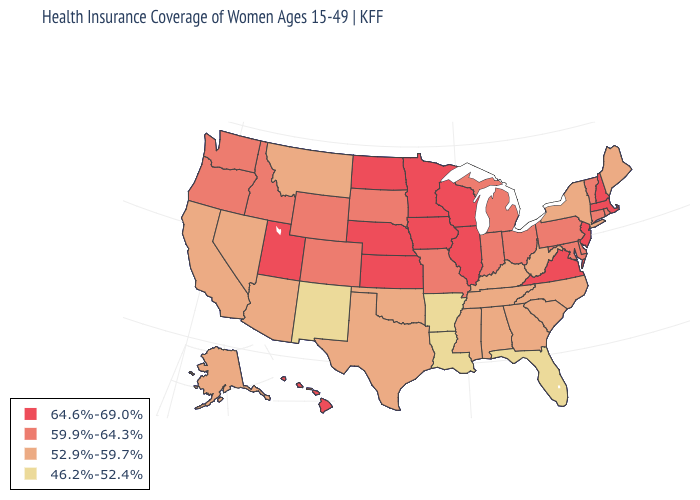Which states hav the highest value in the West?
Keep it brief. Hawaii, Utah. What is the value of Indiana?
Short answer required. 59.9%-64.3%. Name the states that have a value in the range 46.2%-52.4%?
Give a very brief answer. Arkansas, Florida, Louisiana, New Mexico. Does New Jersey have the highest value in the USA?
Keep it brief. Yes. What is the value of Iowa?
Short answer required. 64.6%-69.0%. What is the value of Minnesota?
Quick response, please. 64.6%-69.0%. What is the value of South Carolina?
Give a very brief answer. 52.9%-59.7%. What is the value of Texas?
Concise answer only. 52.9%-59.7%. What is the value of Delaware?
Keep it brief. 59.9%-64.3%. Name the states that have a value in the range 59.9%-64.3%?
Quick response, please. Colorado, Connecticut, Delaware, Idaho, Indiana, Maryland, Michigan, Missouri, Ohio, Oregon, Pennsylvania, Rhode Island, South Dakota, Vermont, Washington, Wyoming. Does Alaska have the same value as Minnesota?
Keep it brief. No. What is the highest value in the USA?
Be succinct. 64.6%-69.0%. What is the value of Wisconsin?
Write a very short answer. 64.6%-69.0%. What is the value of West Virginia?
Answer briefly. 52.9%-59.7%. Name the states that have a value in the range 52.9%-59.7%?
Concise answer only. Alabama, Alaska, Arizona, California, Georgia, Kentucky, Maine, Mississippi, Montana, Nevada, New York, North Carolina, Oklahoma, South Carolina, Tennessee, Texas, West Virginia. 